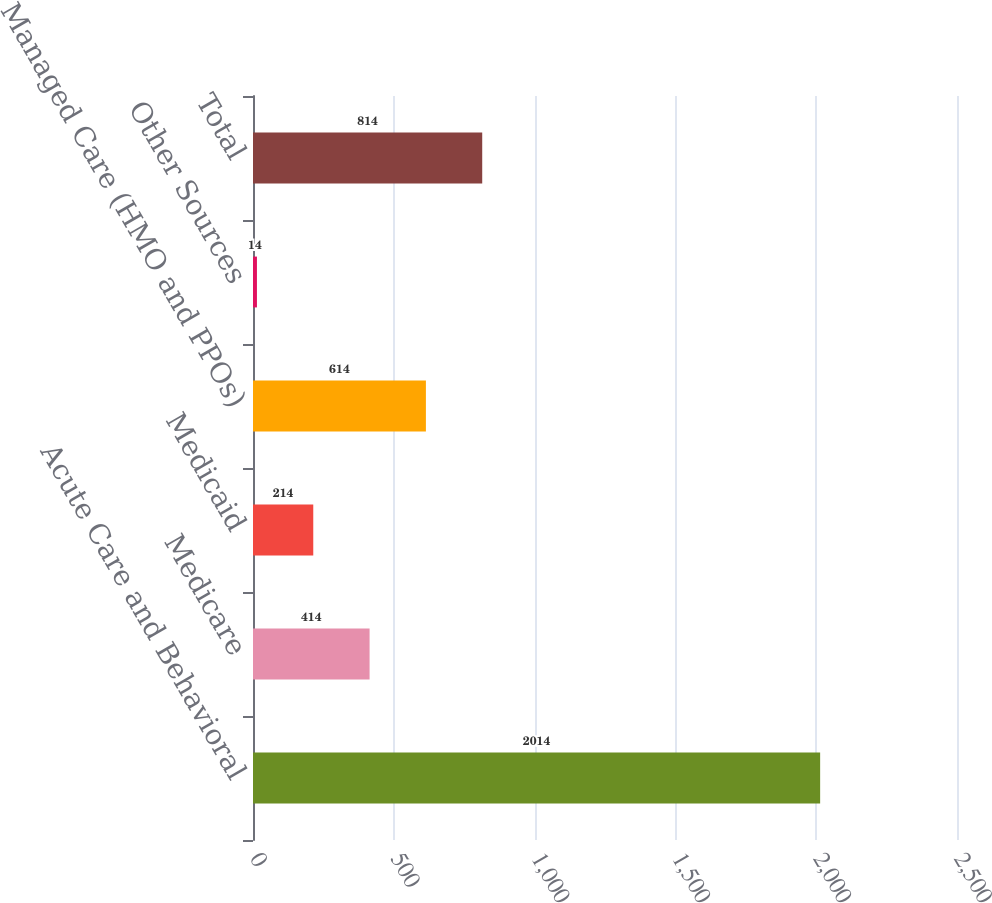<chart> <loc_0><loc_0><loc_500><loc_500><bar_chart><fcel>Acute Care and Behavioral<fcel>Medicare<fcel>Medicaid<fcel>Managed Care (HMO and PPOs)<fcel>Other Sources<fcel>Total<nl><fcel>2014<fcel>414<fcel>214<fcel>614<fcel>14<fcel>814<nl></chart> 